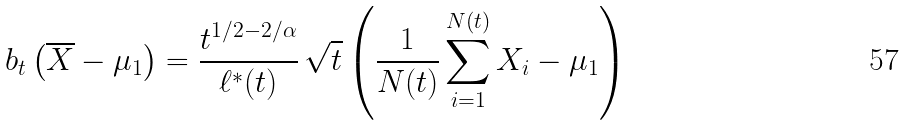Convert formula to latex. <formula><loc_0><loc_0><loc_500><loc_500>b _ { t } \left ( \overline { X } - \mu _ { 1 } \right ) = \frac { t ^ { 1 / 2 - 2 / \alpha } } { \ell ^ { * } ( t ) } \, \sqrt { t } \left ( \frac { 1 } { N ( t ) } \sum _ { i = 1 } ^ { N ( t ) } X _ { i } - \mu _ { 1 } \right )</formula> 